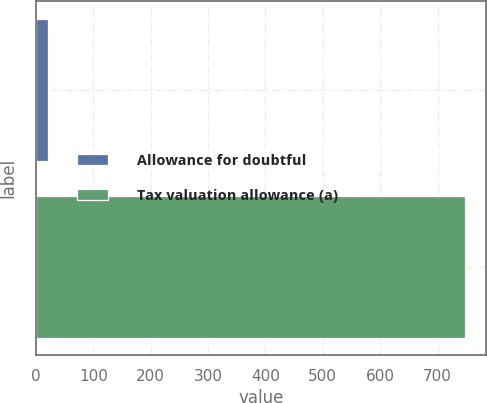<chart> <loc_0><loc_0><loc_500><loc_500><bar_chart><fcel>Allowance for doubtful<fcel>Tax valuation allowance (a)<nl><fcel>21<fcel>747<nl></chart> 